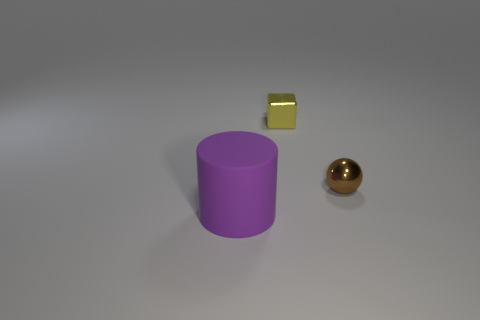Add 3 small red spheres. How many objects exist? 6 Subtract all cylinders. How many objects are left? 2 Subtract all large purple objects. Subtract all big objects. How many objects are left? 1 Add 1 metallic cubes. How many metallic cubes are left? 2 Add 2 small shiny cubes. How many small shiny cubes exist? 3 Subtract 0 cyan cylinders. How many objects are left? 3 